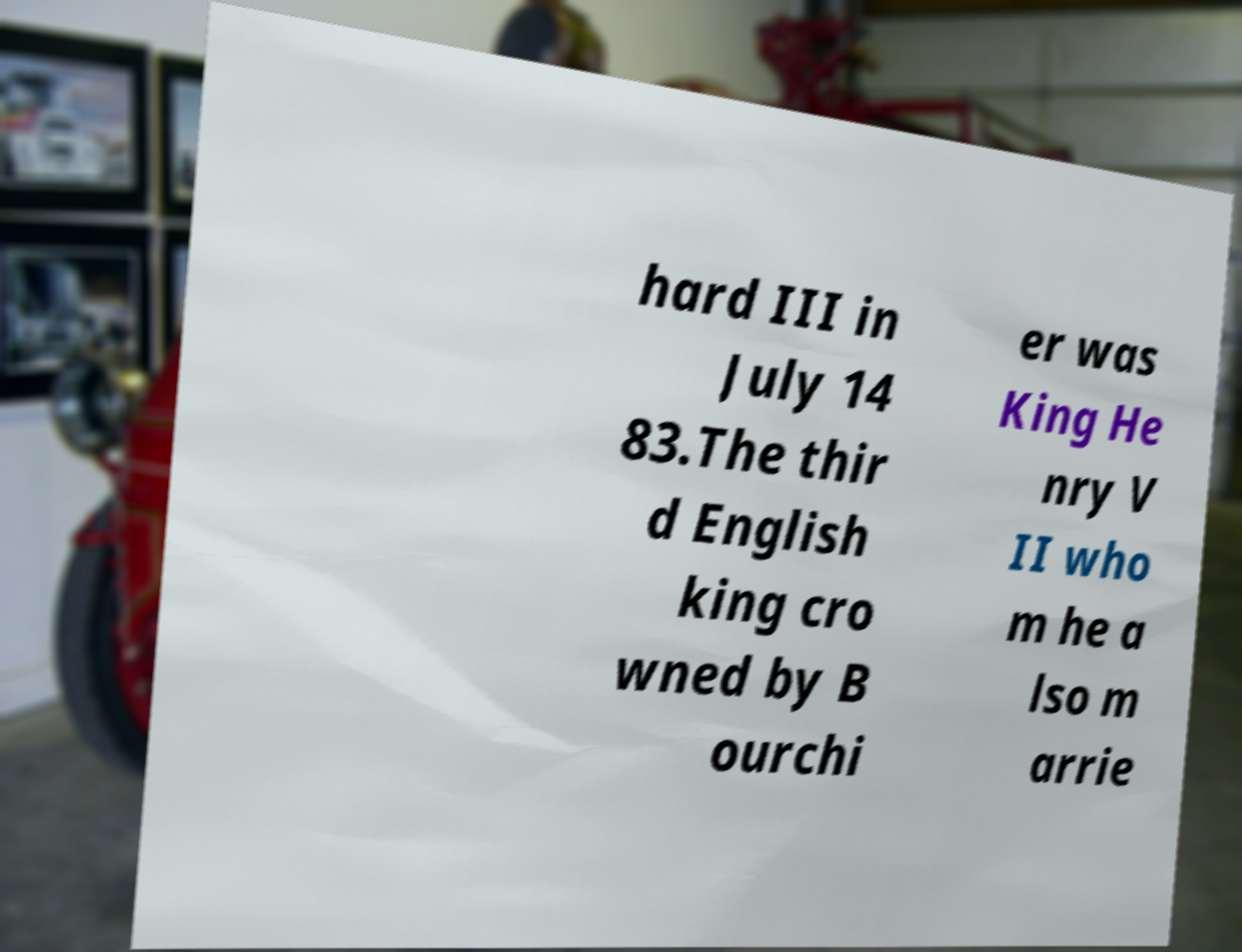What messages or text are displayed in this image? I need them in a readable, typed format. hard III in July 14 83.The thir d English king cro wned by B ourchi er was King He nry V II who m he a lso m arrie 